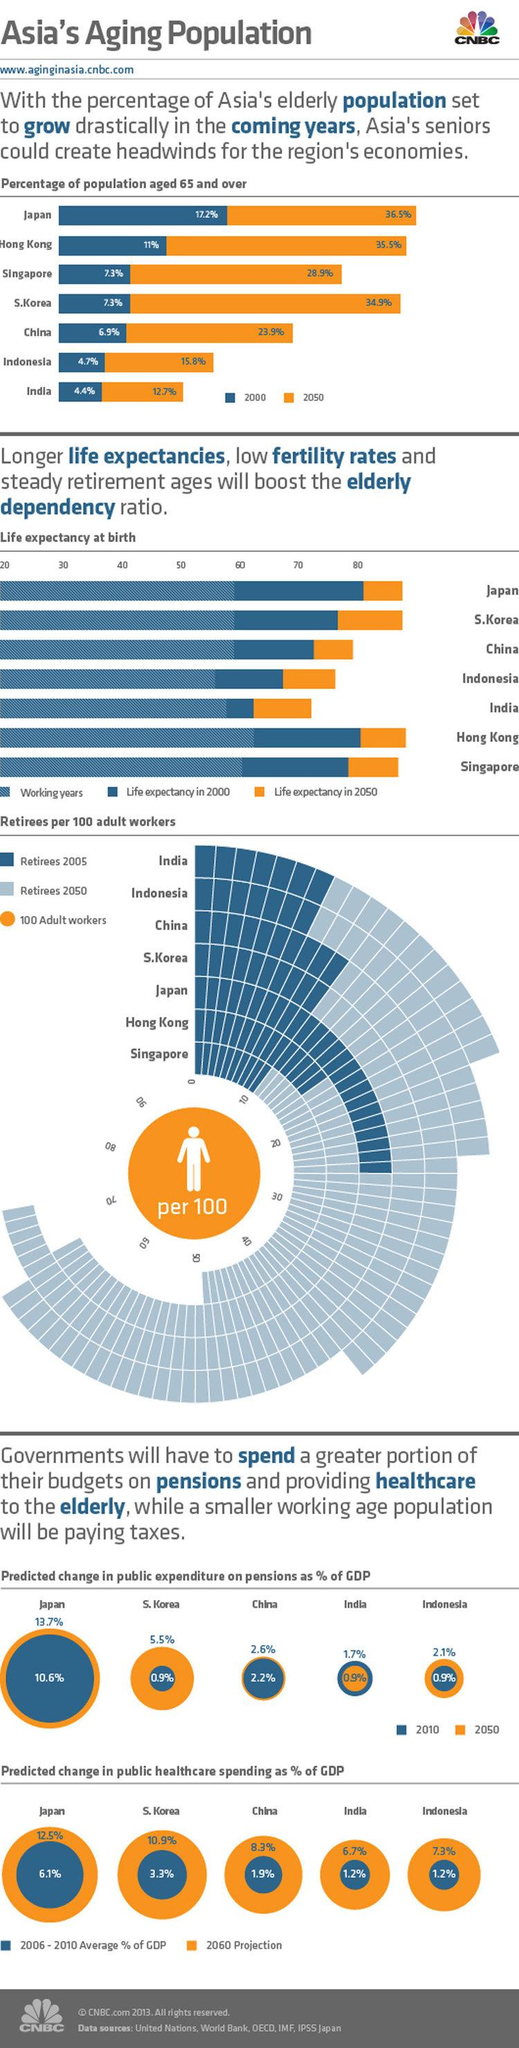Outline some significant characteristics in this image. In 2000, the percentage of the population aged 65 and over in Singapore was 21.6%. By 2050, this population segment is projected to increase to 21.6%. In 2050, the percentage of the population aged 65 and over in Hong Kong was projected to be 24.5%, which was an increase from 2000 when the percentage was 14.3%. In 2000, the percentage of the population aged 65 and over in China was 7%, while in 2050, this percentage increased to 16%. The percentage of the population aged 65 and over in Japan between 2000 and 2050 was 19.3%. 